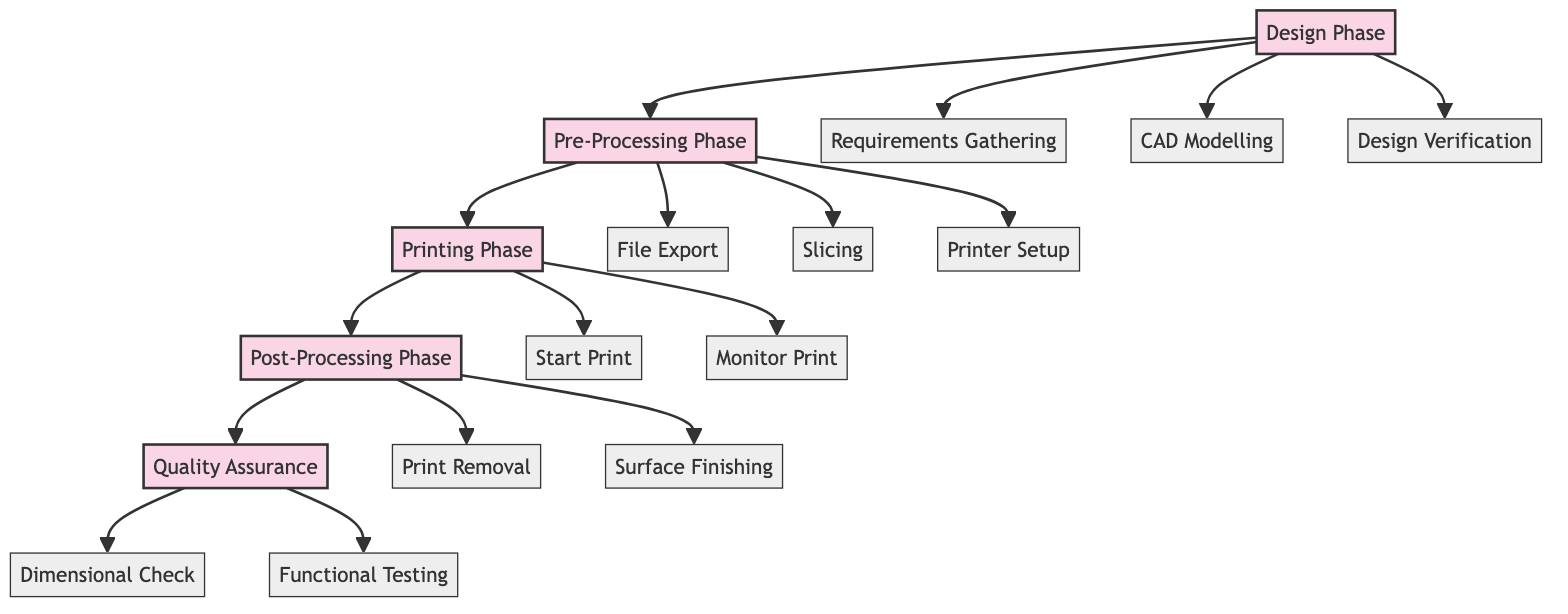What are the three main phases in the workflow? The diagram shows five main phases: Design Phase, Pre-Processing Phase, Printing Phase, Post-Processing Phase, and Quality Assurance.
Answer: Design Phase, Pre-Processing Phase, Printing Phase How many sub-elements are there in the Printing Phase? The Printing Phase contains two sub-elements: Start Print and Monitor Print. In total, there are 2 sub-elements in this phase.
Answer: 2 What phase comes directly after Pre-Processing Phase? The diagram depicts a sequential flow with arrows. The phase that follows Pre-Processing Phase is Printing Phase.
Answer: Printing Phase Which sub-element is responsible for creating a 3D model of the part? Within the Design Phase, the sub-element CAD Modelling is identified as the process for creating a 3D model of the part.
Answer: CAD Modelling What action is taken during 'Surface Finishing'? In the Post-Processing Phase, the action of Surface Finishing encompasses post-processing steps like sanding, smoothing, or painting.
Answer: Sanding, smoothing, or painting What is the final phase in the workflow? The diagram illustrates that the last phase in the workflow sequence is Quality Assurance.
Answer: Quality Assurance How does the pre-processing phase connect to the printing phase? The diagram displays an arrow that connects Pre-Processing Phase directly to Printing Phase, indicating that the pre-processing actions are prerequisites to printing.
Answer: Through an arrow Which two checks are performed during Quality Assurance? The Quality Assurance phase consists of two checks: Dimensional Check and Functional Testing, which verify the part's dimensions and its performance.
Answer: Dimensional Check, Functional Testing What happens after the 'Start Print' sub-element? After the Start Print sub-element in the Printing Phase is initiated, the next sub-element is Monitor Print, which involves overseeing the printing process.
Answer: Monitor Print 